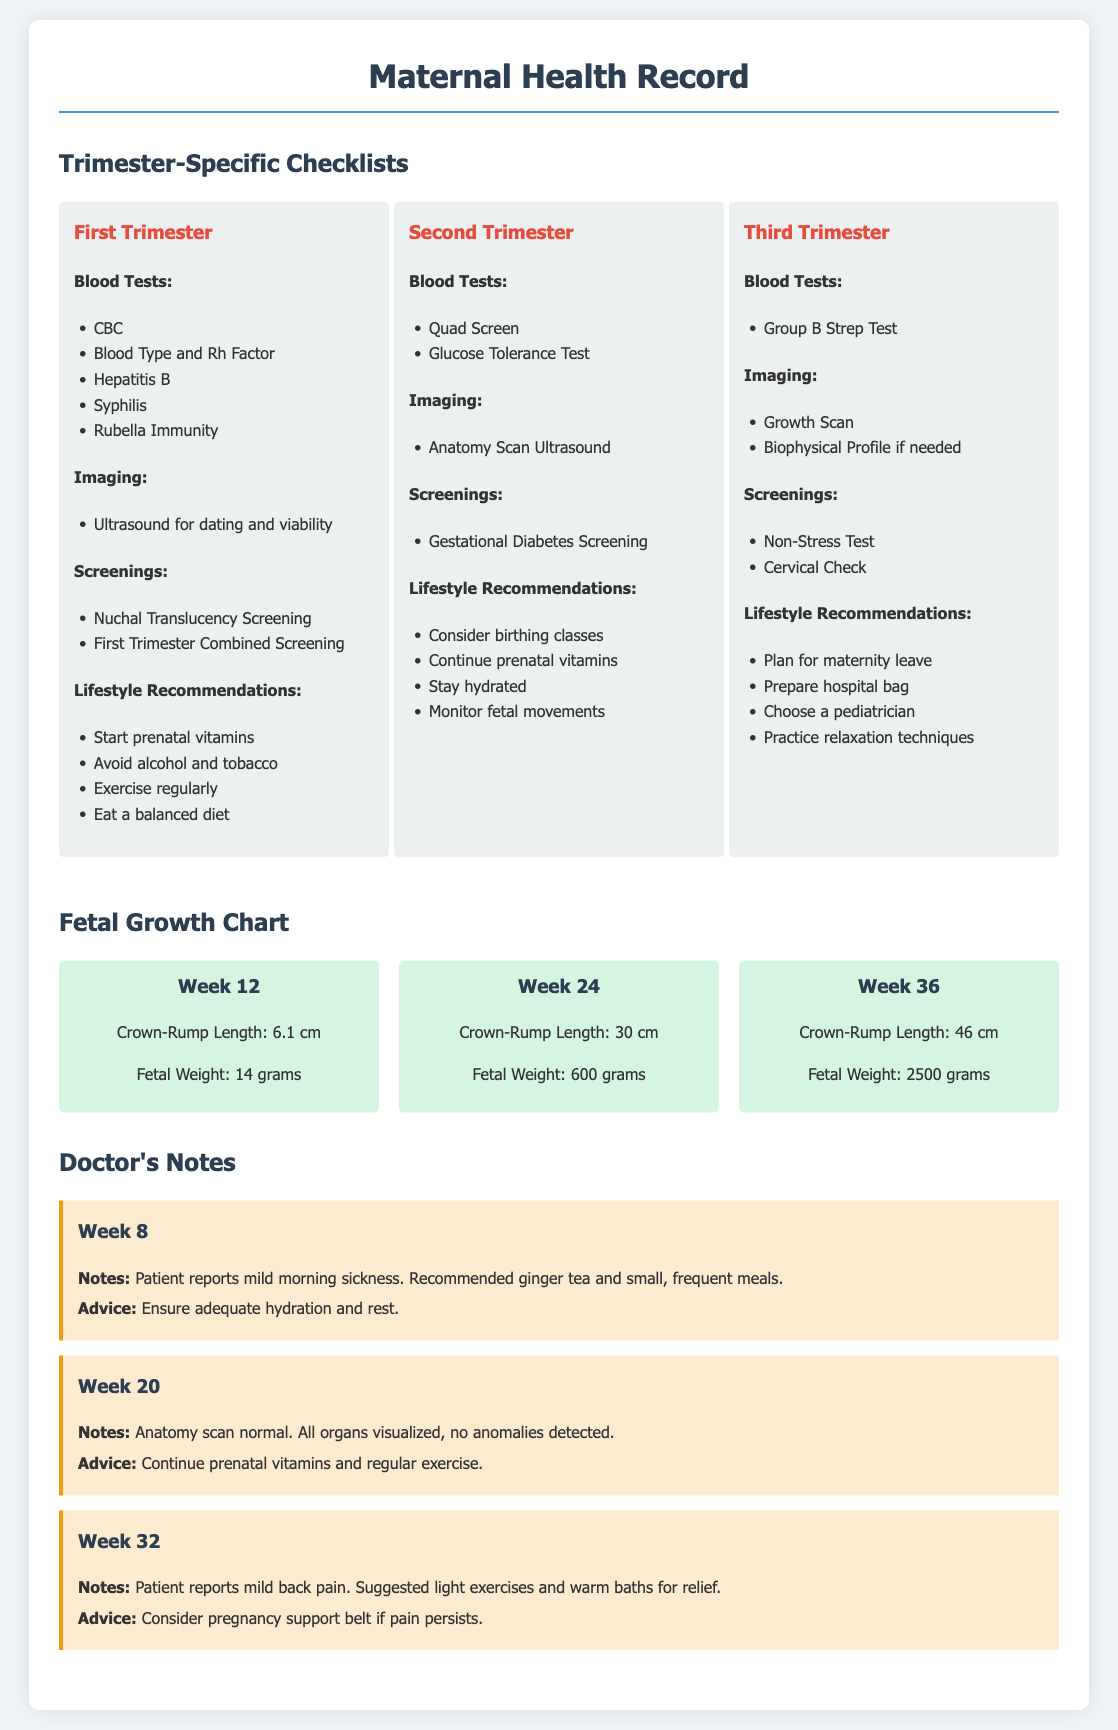What blood tests are recommended in the first trimester? The first trimester checklist includes several blood tests: CBC, Blood Type and Rh Factor, Hepatitis B, Syphilis, and Rubella Immunity.
Answer: CBC, Blood Type and Rh Factor, Hepatitis B, Syphilis, Rubella Immunity What fetal weight is expected at week 24? According to the fetal growth chart for week 24, the fetal weight is 600 grams.
Answer: 600 grams What is a recommended lifestyle change during the second trimester? The second trimester checklist recommends considering birthing classes and continuing prenatal vitamins, among other recommendations.
Answer: Consider birthing classes Which week has a note regarding mild back pain? The doctor's note for week 32 mentions that the patient reports mild back pain.
Answer: Week 32 What imaging test is performed during the third trimester? The checklist for the third trimester includes a Growth Scan as an imaging test.
Answer: Growth Scan 